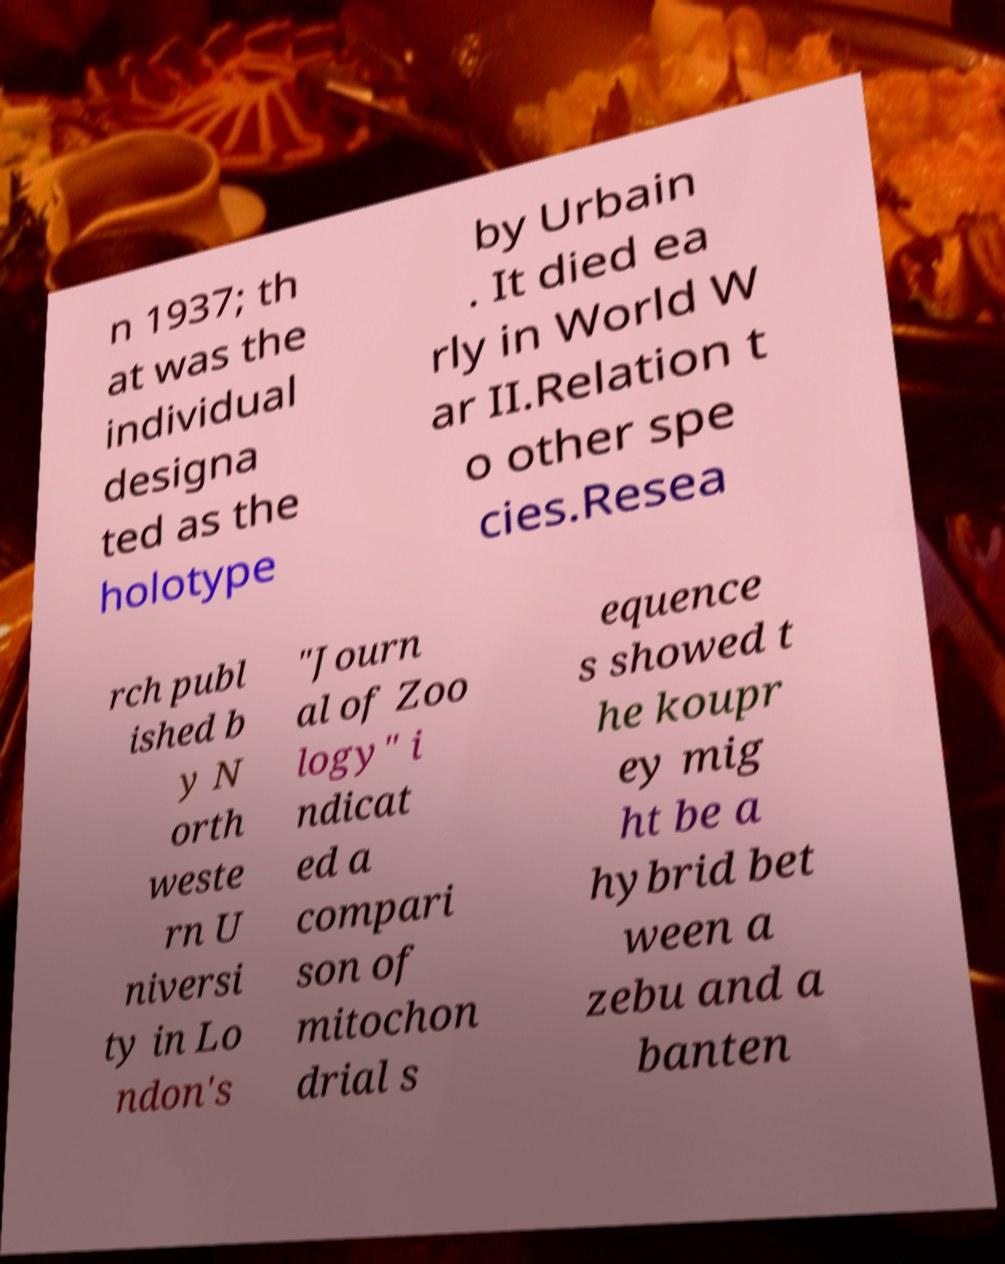Can you read and provide the text displayed in the image?This photo seems to have some interesting text. Can you extract and type it out for me? n 1937; th at was the individual designa ted as the holotype by Urbain . It died ea rly in World W ar II.Relation t o other spe cies.Resea rch publ ished b y N orth weste rn U niversi ty in Lo ndon's "Journ al of Zoo logy" i ndicat ed a compari son of mitochon drial s equence s showed t he koupr ey mig ht be a hybrid bet ween a zebu and a banten 